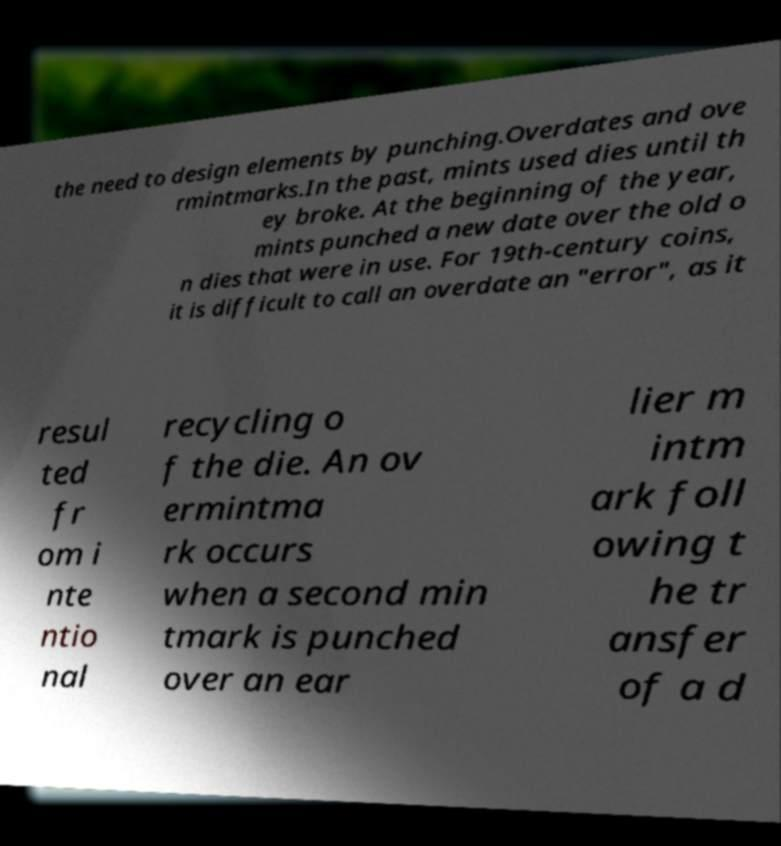Can you read and provide the text displayed in the image?This photo seems to have some interesting text. Can you extract and type it out for me? the need to design elements by punching.Overdates and ove rmintmarks.In the past, mints used dies until th ey broke. At the beginning of the year, mints punched a new date over the old o n dies that were in use. For 19th-century coins, it is difficult to call an overdate an "error", as it resul ted fr om i nte ntio nal recycling o f the die. An ov ermintma rk occurs when a second min tmark is punched over an ear lier m intm ark foll owing t he tr ansfer of a d 